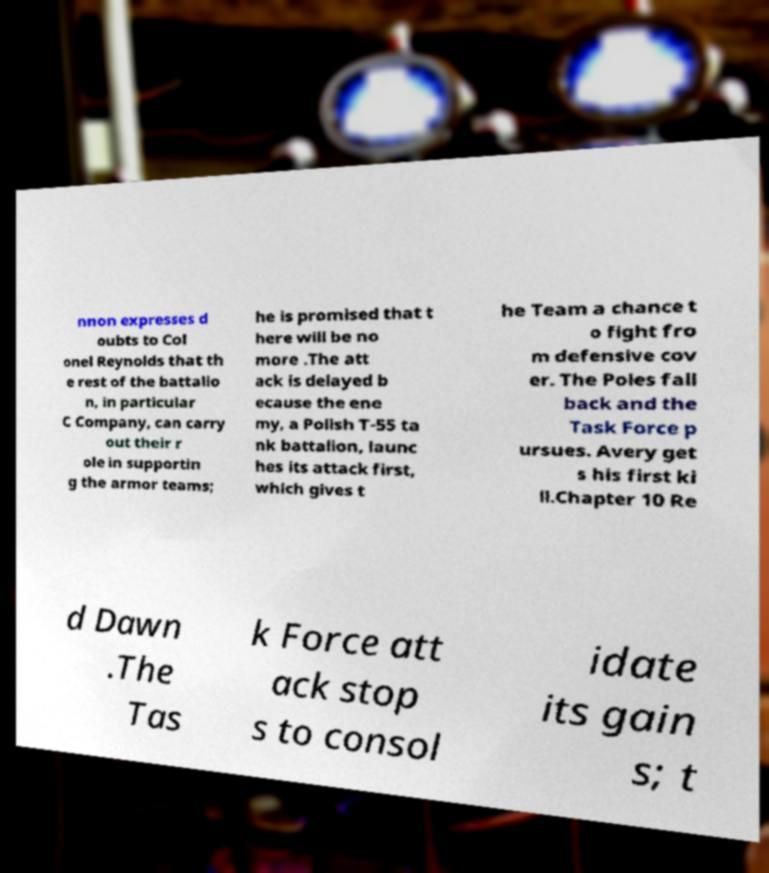For documentation purposes, I need the text within this image transcribed. Could you provide that? nnon expresses d oubts to Col onel Reynolds that th e rest of the battalio n, in particular C Company, can carry out their r ole in supportin g the armor teams; he is promised that t here will be no more .The att ack is delayed b ecause the ene my, a Polish T-55 ta nk battalion, launc hes its attack first, which gives t he Team a chance t o fight fro m defensive cov er. The Poles fall back and the Task Force p ursues. Avery get s his first ki ll.Chapter 10 Re d Dawn .The Tas k Force att ack stop s to consol idate its gain s; t 